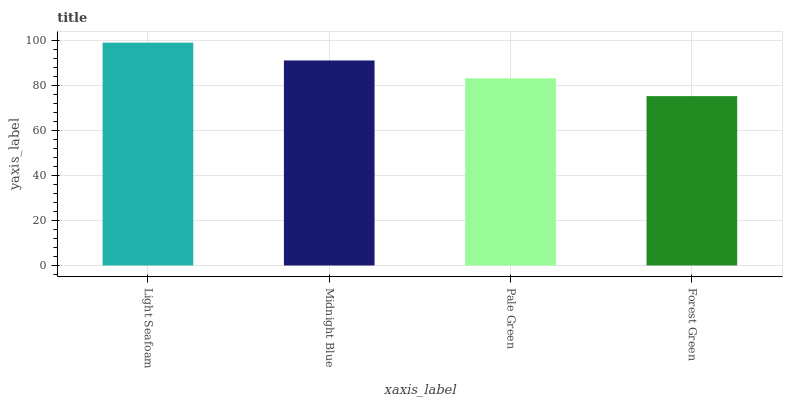Is Forest Green the minimum?
Answer yes or no. Yes. Is Light Seafoam the maximum?
Answer yes or no. Yes. Is Midnight Blue the minimum?
Answer yes or no. No. Is Midnight Blue the maximum?
Answer yes or no. No. Is Light Seafoam greater than Midnight Blue?
Answer yes or no. Yes. Is Midnight Blue less than Light Seafoam?
Answer yes or no. Yes. Is Midnight Blue greater than Light Seafoam?
Answer yes or no. No. Is Light Seafoam less than Midnight Blue?
Answer yes or no. No. Is Midnight Blue the high median?
Answer yes or no. Yes. Is Pale Green the low median?
Answer yes or no. Yes. Is Pale Green the high median?
Answer yes or no. No. Is Light Seafoam the low median?
Answer yes or no. No. 